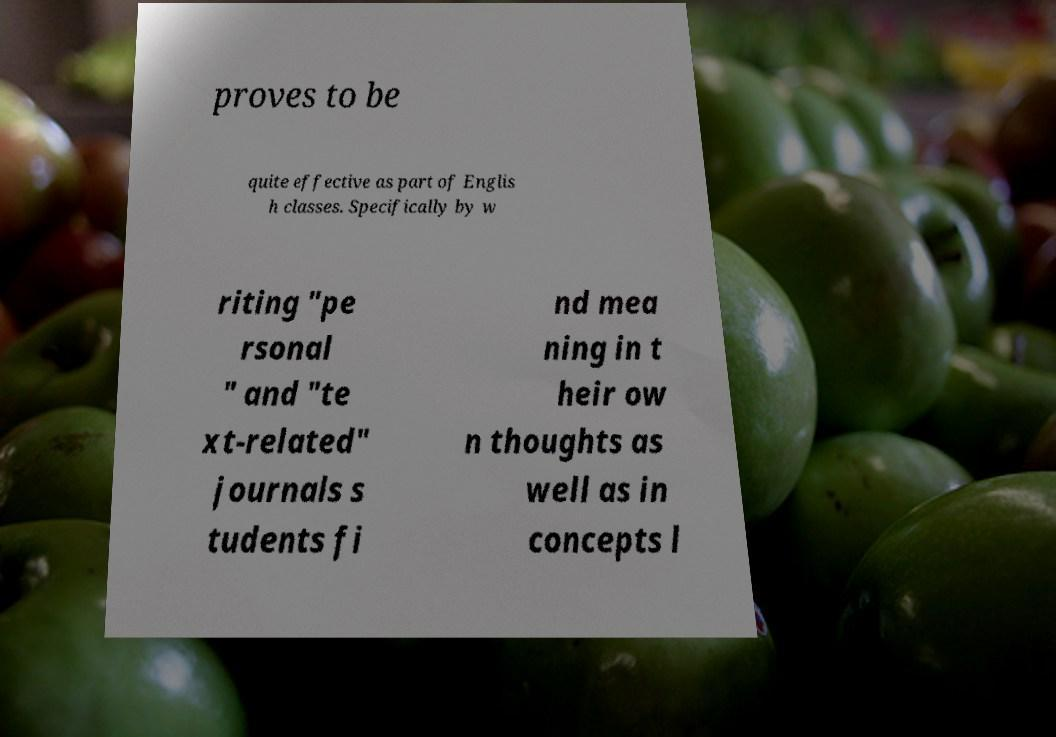Can you read and provide the text displayed in the image?This photo seems to have some interesting text. Can you extract and type it out for me? proves to be quite effective as part of Englis h classes. Specifically by w riting "pe rsonal " and "te xt-related" journals s tudents fi nd mea ning in t heir ow n thoughts as well as in concepts l 